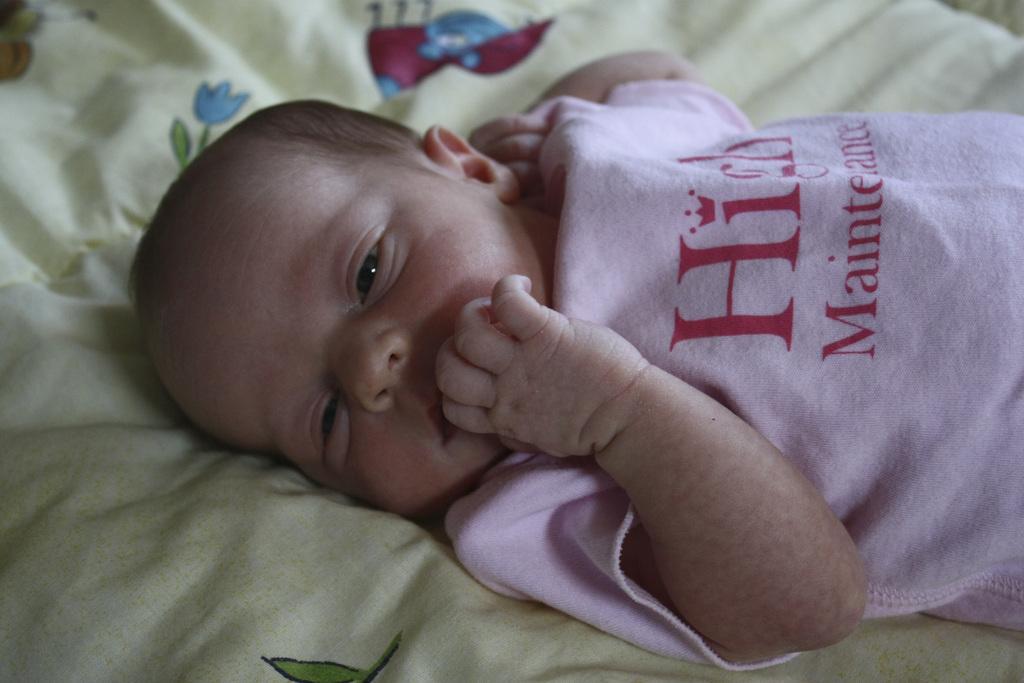In one or two sentences, can you explain what this image depicts? In this picture we can see a baby lying on a cloth. 